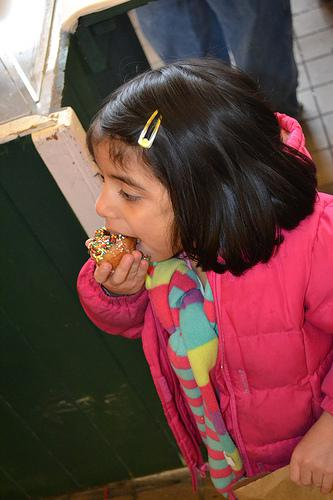Question: what color is the girl's hair?
Choices:
A. Blonde.
B. Red.
C. Brown.
D. Black.
Answer with the letter. Answer: D Question: what is the girl doing?
Choices:
A. Reading.
B. Studying.
C. Eating.
D. Drinking.
Answer with the letter. Answer: C Question: what color is the girl's jacket?
Choices:
A. Red.
B. Blue.
C. Black.
D. Pink.
Answer with the letter. Answer: D Question: what color is the floor?
Choices:
A. Black.
B. White.
C. Brown.
D. Red.
Answer with the letter. Answer: B Question: how many donuts are in the photograph?
Choices:
A. Two.
B. One.
C. Three.
D. Four.
Answer with the letter. Answer: B 